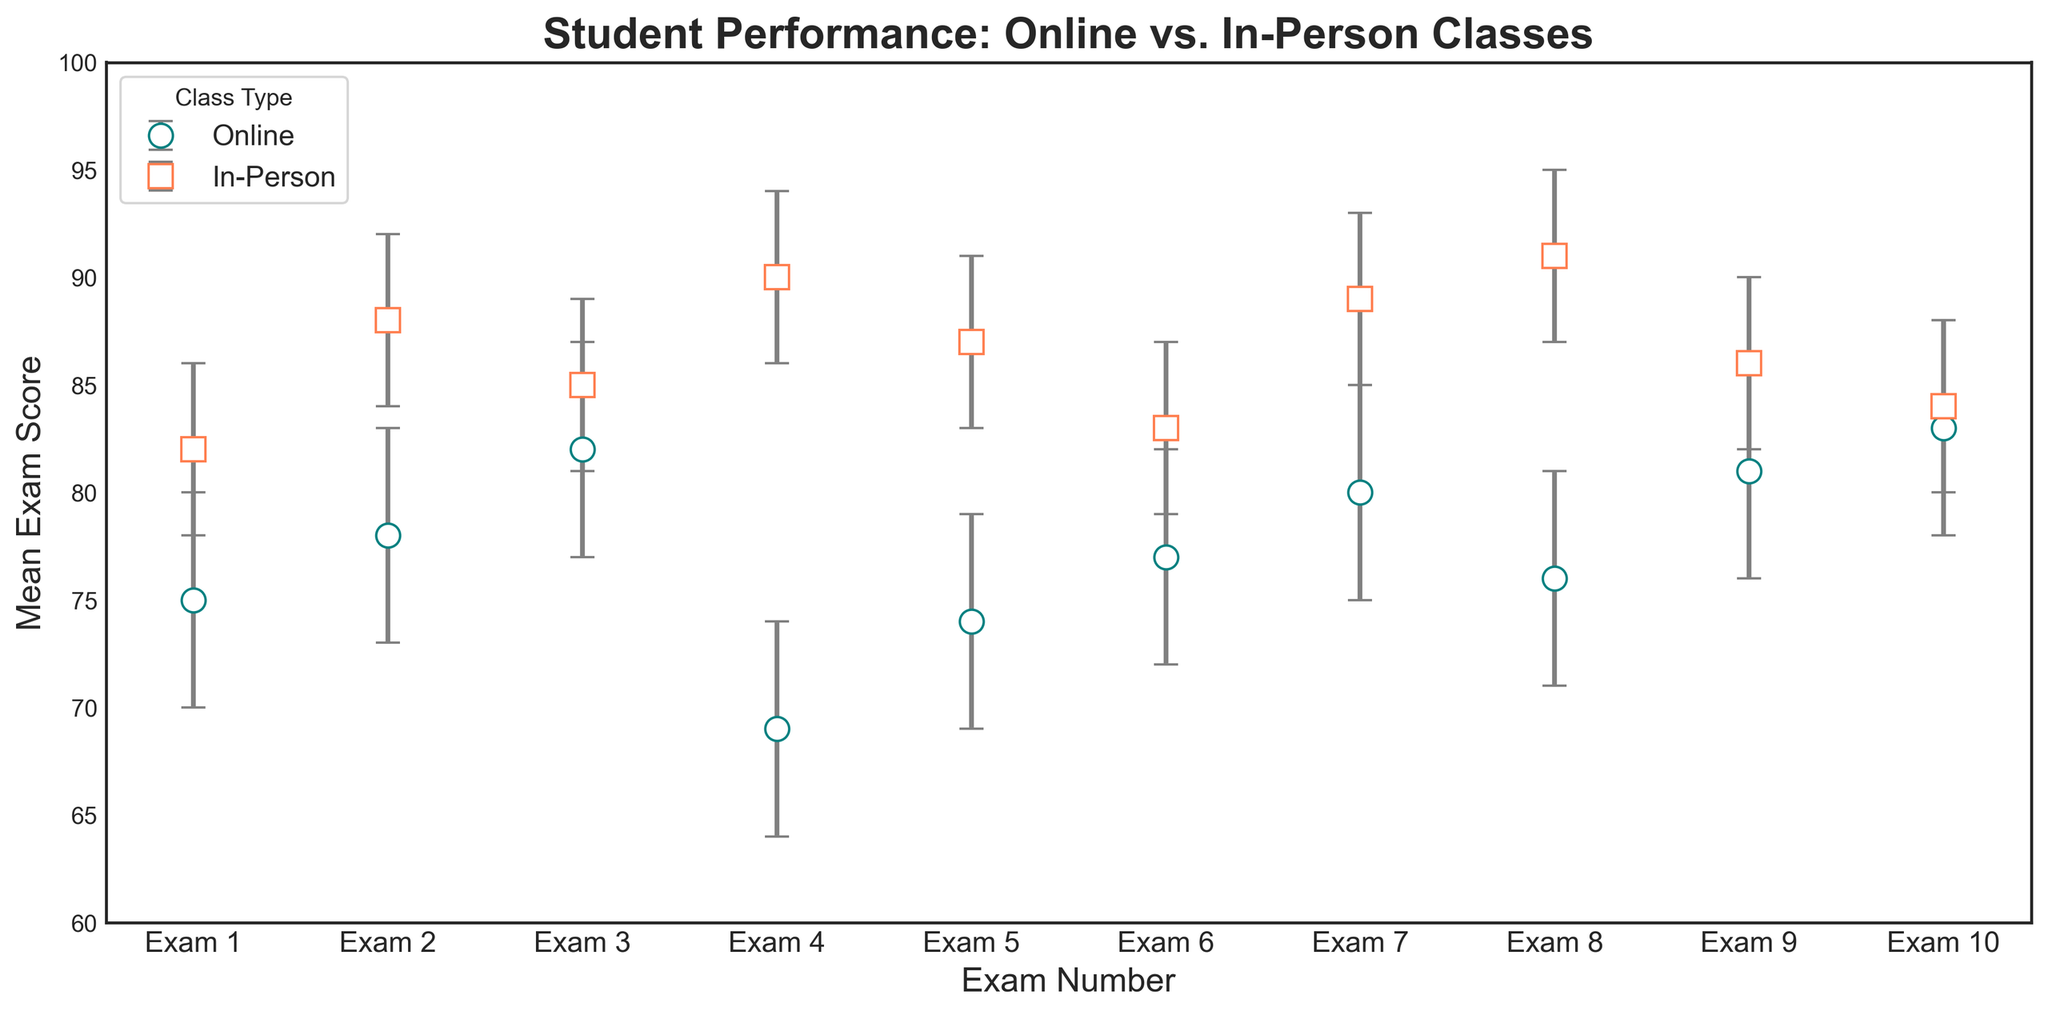What is the mean score for the first Online exam? The first Online exam is indicated by the first data point for the "Online" class type. The corresponding mean score is 75.
Answer: 75 Which class type has the highest mean score overall? The highest mean score in the plot can be found by checking the peaks of the error bars for both class types. The highest mean score is for the "In-Person" class type at 91.
Answer: In-Person What is the difference in the mean score between the second Online exam and the second In-Person exam? The mean score for the second Online exam is 78, and for the second In-Person exam, it is 88. The difference is 88 - 78.
Answer: 10 How many exams have a higher mean score in Online classes compared to In-Person classes? By comparing each exam, none of the Online class exams have higher mean scores than the corresponding In-Person class exams.
Answer: 0 What is the range of the confidence interval for the third In-Person exam? The third In-Person exam has a mean score of 85 with an upper bound of 89 and a lower bound of 81. The range of the confidence interval is 89 - 81.
Answer: 8 For which exam does the Online class have the smallest confidence interval range? By examining the lengths of the error bars for each Online exam, the fourth exam has the smallest range. It has a mean score of 69 with an upper bound of 74 and a lower bound of 64, giving a range of 74 - 64.
Answer: Fourth exam Compare the lower bounds of the confidence intervals for the fourth Online exam and the fourth In-Person exam. Which one is higher? For the fourth Online exam, the lower bound is 64, and for the fourth In-Person exam, the lower bound is 86. The fourth In-Person exam has a higher lower bound.
Answer: In-Person Which class type demonstrates less variability in mean scores? By visually assessing the error bars' spread for each class type, the error bars for the "In-Person" class type show less variability compared to "Online" classes.
Answer: In-Person 